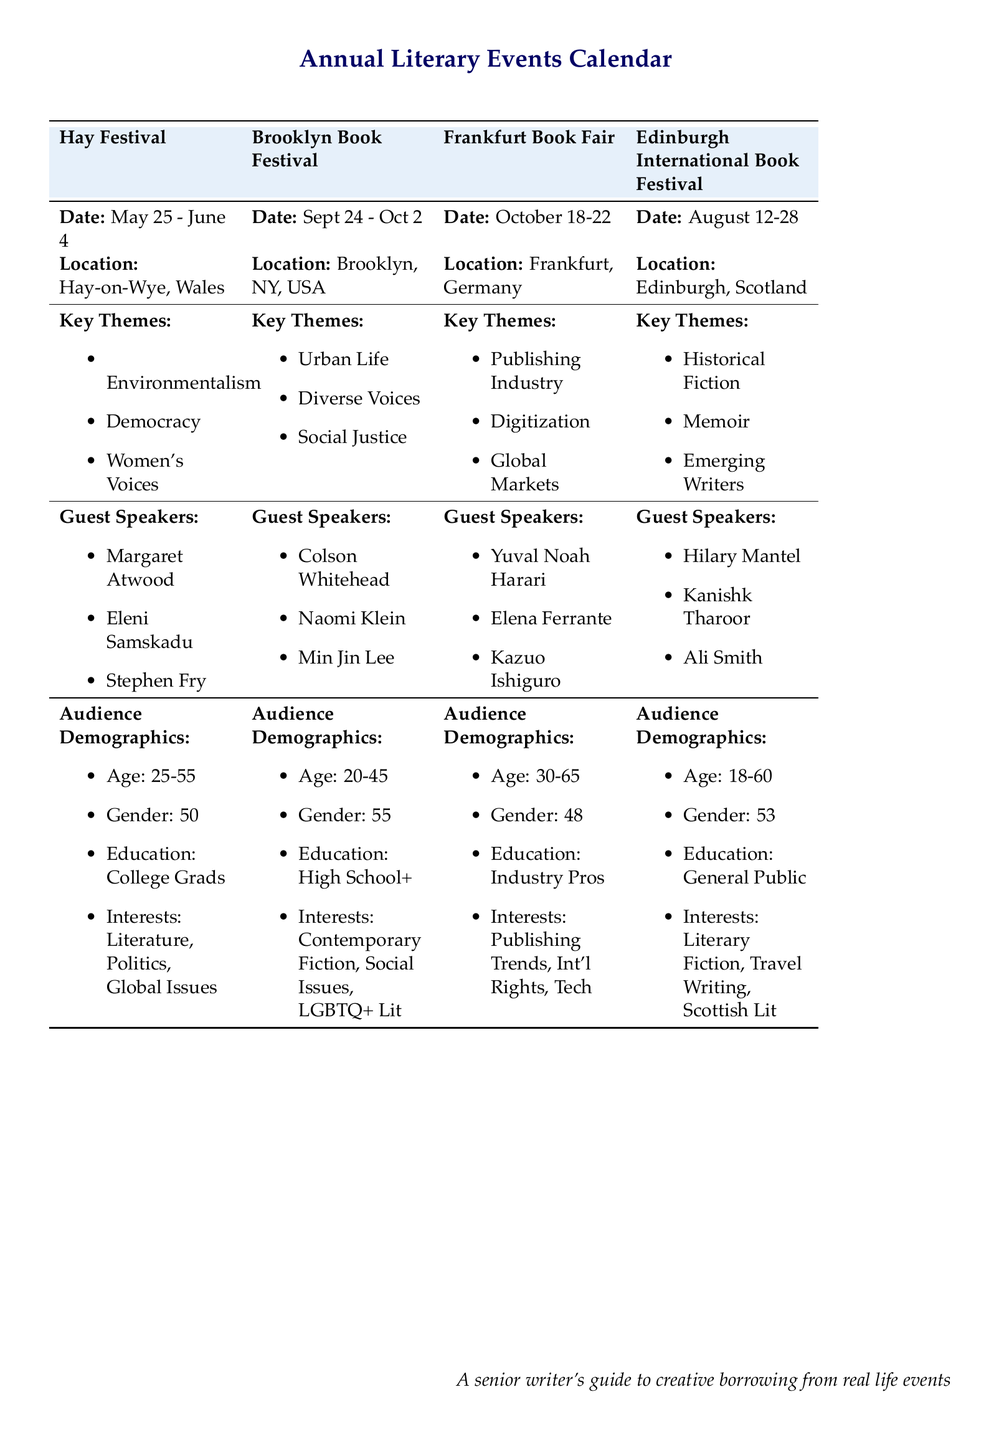What is the location of the Hay Festival? The location is specified in the document as Hay-on-Wye, Wales.
Answer: Hay-on-Wye, Wales Who is a guest speaker at the Brooklyn Book Festival? The document lists several guest speakers for the Brooklyn Book Festival, including Colson Whitehead.
Answer: Colson Whitehead What are the key themes of the Frankfurt Book Fair? The themes listed in the document for this event include Publishing Industry, Digitization, and Global Markets.
Answer: Publishing Industry, Digitization, Global Markets What is the age range of the audience for the Edinburgh International Book Festival? The document states the audience age range is 18-60.
Answer: 18-60 Which literary event includes a theme related to Women's Voices? Referring to the themes listed, the Hay Festival includes Women's Voices as one of its key themes.
Answer: Hay Festival What percentage of audience attendees at the Brooklyn Book Festival are female? The demographic information mentions that 55% of the audience are female.
Answer: 55% How many days does the Hay Festival run? The document provides specific dates, stating it runs from May 25 to June 4, which indicates it lasts 11 days.
Answer: 11 days Who is one of the guest speakers at the Edinburgh International Book Festival? The document lists Hilary Mantel as a guest speaker for this event.
Answer: Hilary Mantel What theme is a feature of both Hay Festival and Brooklyn Book Festival? Looking at the themes, Environmentalism appears in the Hay Festival and Diverse Voices in the Brooklyn Book Festival; however, there are no overlaps listed. This question is designed to understand thematic diversity.
Answer: None 